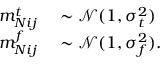<formula> <loc_0><loc_0><loc_500><loc_500>\begin{array} { r l } { m _ { N i j } ^ { t } } & \sim \mathcal { N } ( 1 , \sigma _ { t } ^ { 2 } ) } \\ { m _ { N i j } ^ { f } } & \sim \mathcal { N } ( 1 , \sigma _ { f } ^ { 2 } ) . } \end{array}</formula> 